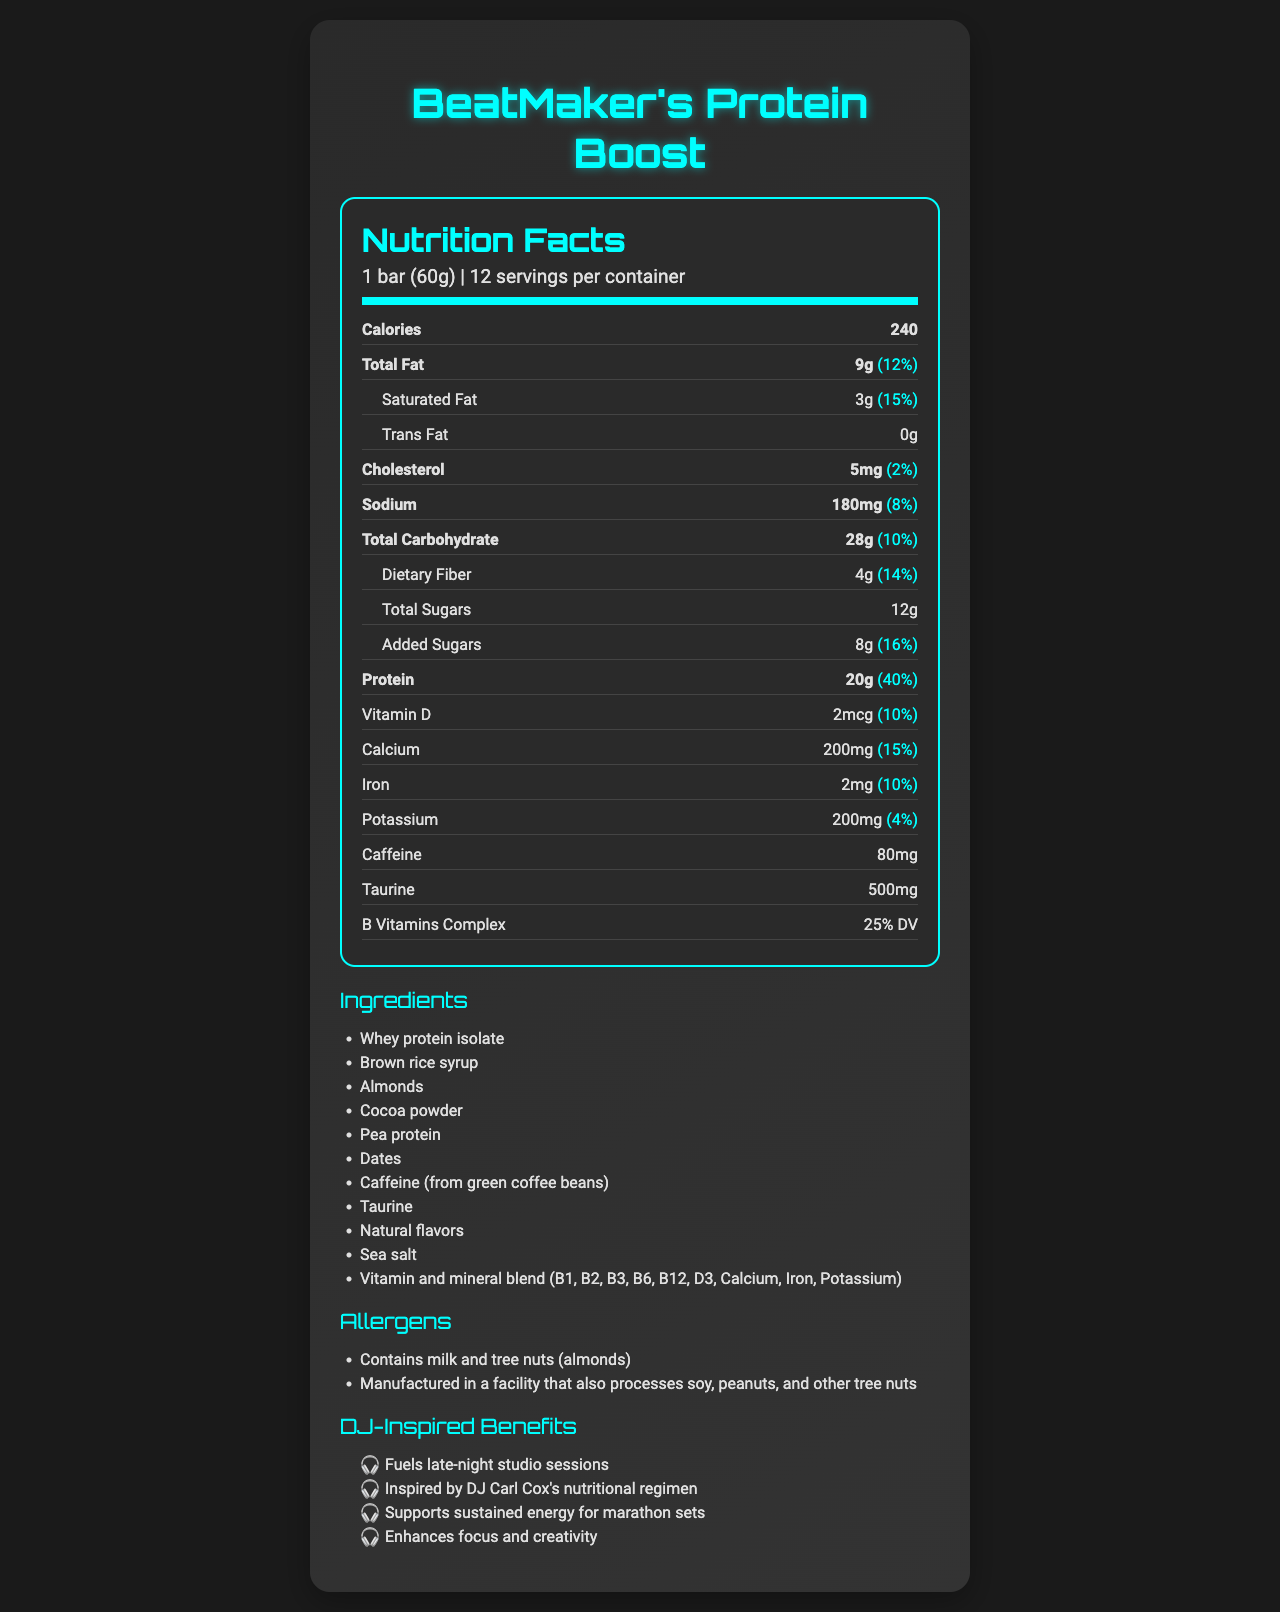what is the serving size of BeatMaker's Protein Boost? The document clearly specifies that the serving size is 1 bar, which weighs 60 grams.
Answer: 1 bar (60g) how many servings are there per container? According to the document, each container holds 12 servings.
Answer: 12 what is the amount of protein per serving? The document lists the protein content as 20g per bar.
Answer: 20g how much calcium is in one serving? The document indicates that each serving contains 200mg of calcium.
Answer: 200mg what are the allergens present in BeatMaker's Protein Boost? The allergens section states that the product contains milk and tree nuts (almonds).
Answer: Milk and tree nuts (almonds) how many calories are in one bar? The document specifies that each bar contains 240 calories.
Answer: 240 how much caffeine is in one serving? The document lists the caffeine content as 80mg per serving.
Answer: 80mg which ingredient is the main source of protein in BeatMaker's Protein Boost? By checking the ingredients list, it's clear that whey protein isolate is the main source of protein.
Answer: Whey protein isolate how much is the daily value percentage for Vitamin D? A. 5% B. 10% C. 15% D. 20% According to the document, the daily value percentage for Vitamin D is 10%.
Answer: B. 10% which vitamin is included in the B Vitamins Complex? A. Vitamin B6 B. Vitamin C C. Vitamin E D. Vitamin K The B Vitamins Complex includes Vitamin B1, B2, B3, B6, and B12, among others.
Answer: A. Vitamin B6 does BeatMaker's Protein Boost contain any trans fat? The document clearly states that the amount of trans fat is 0g.
Answer: No is BeatMaker's Protein Boost marketed specifically for DJs? The marketing claims highlight that the product is inspired by DJ Carl Cox's nutritional regimen and supports DJ-specific needs like sustained energy and focus.
Answer: Yes summarize the nutritional benefits and purposes of BeatMaker's Protein Boost. The document provides a comprehensive overview that sums up the nutritional benefits and target audience of the protein bar.
Answer: BeatMaker's Protein Boost is a protein bar tailored for music producers and DJs. With each bar having 240 calories, 20g of protein, and essential vitamins and minerals, it supports sustained energy, focus, and overall nutritional needs during long studio sessions or marathon sets. The product is inspired by DJ Carl Cox’s diet and is designed to enhance creativity and mental sharpness. what was DJ Carl Cox's specific dietary regimen that inspired this product? The document states that the product is inspired by DJ Carl Cox’s nutritional regimen but doesn't provide specific details about his diet.
Answer: Not enough information 